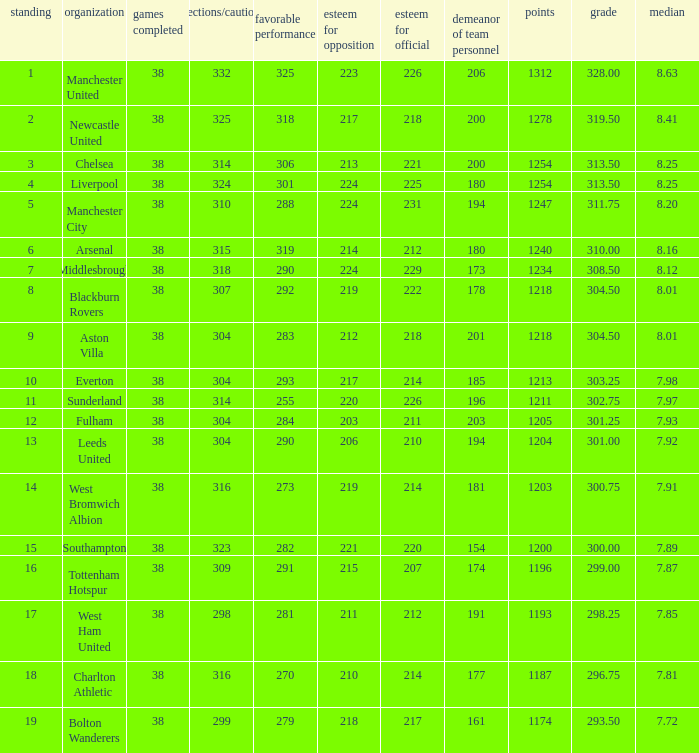Name the pos for west ham united 17.0. 